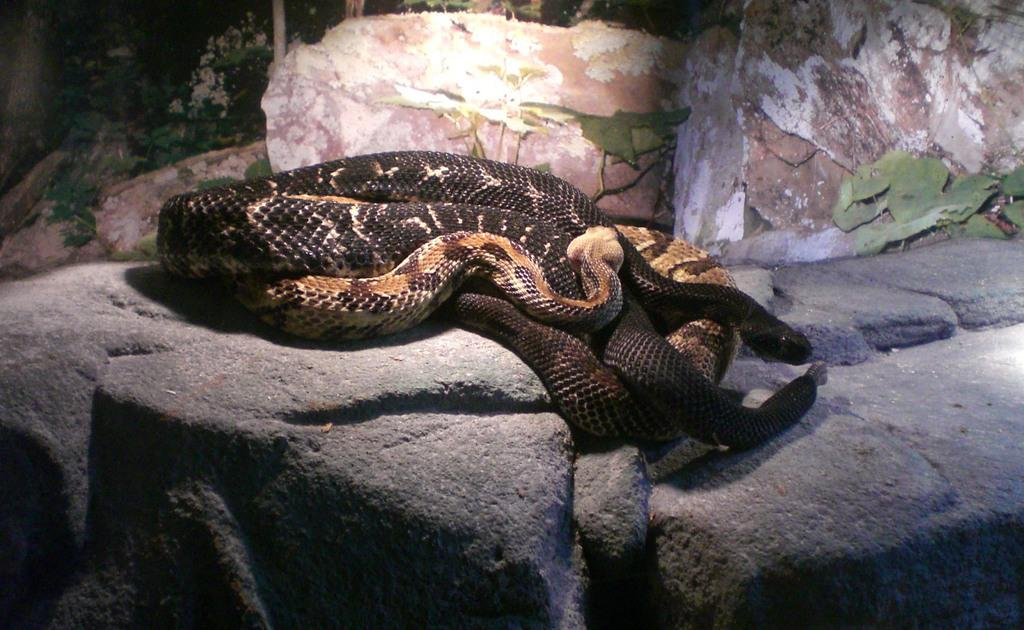How many snakes are present in the image? There are two snakes in the image. What are the snakes doing in the image? The snakes are laying on a rock. What type of advice can be seen written on the rock in the image? There is no advice written on the rock in the image; it only shows two snakes laying on it. 